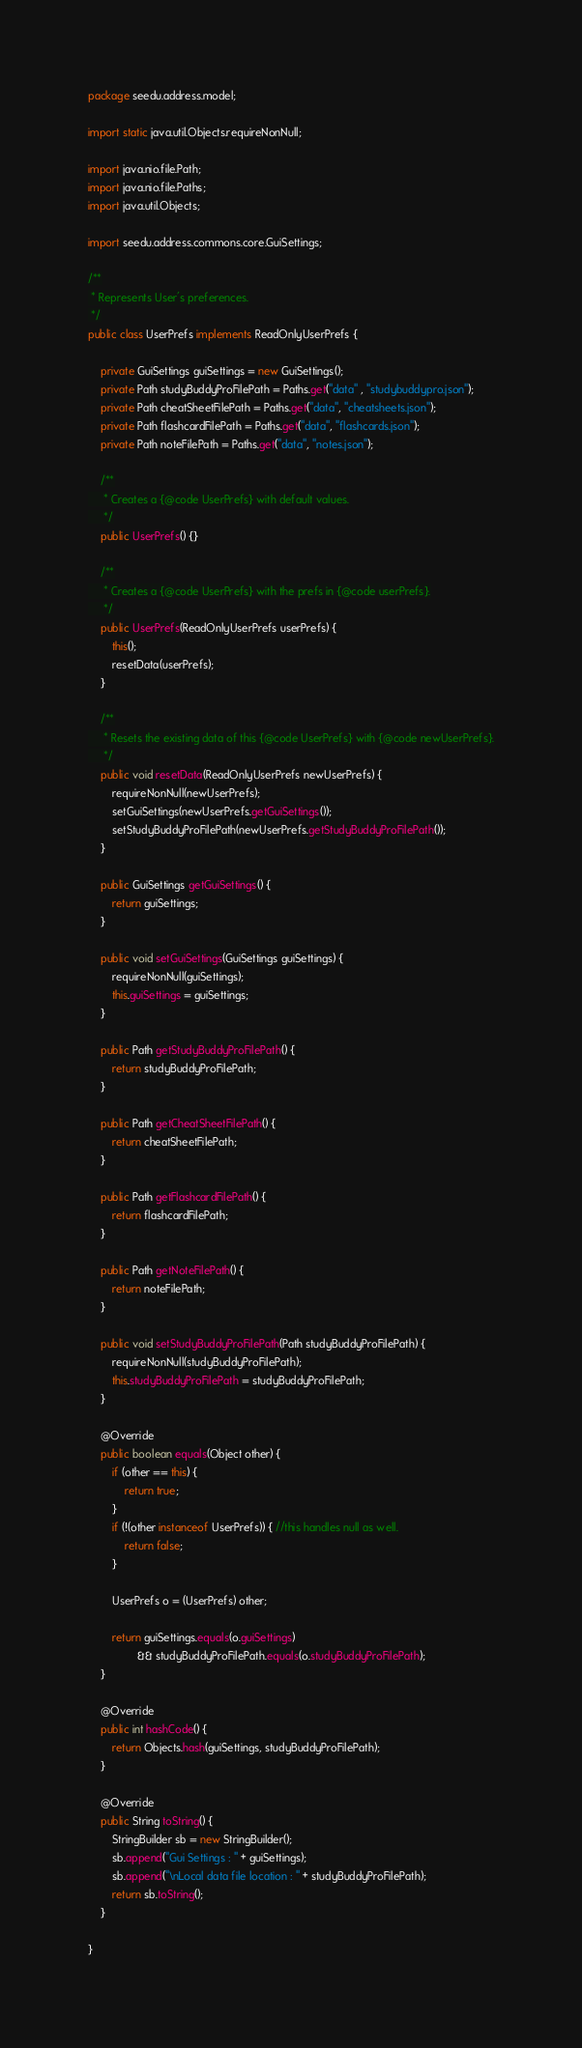<code> <loc_0><loc_0><loc_500><loc_500><_Java_>package seedu.address.model;

import static java.util.Objects.requireNonNull;

import java.nio.file.Path;
import java.nio.file.Paths;
import java.util.Objects;

import seedu.address.commons.core.GuiSettings;

/**
 * Represents User's preferences.
 */
public class UserPrefs implements ReadOnlyUserPrefs {

    private GuiSettings guiSettings = new GuiSettings();
    private Path studyBuddyProFilePath = Paths.get("data" , "studybuddypro.json");
    private Path cheatSheetFilePath = Paths.get("data", "cheatsheets.json");
    private Path flashcardFilePath = Paths.get("data", "flashcards.json");
    private Path noteFilePath = Paths.get("data", "notes.json");

    /**
     * Creates a {@code UserPrefs} with default values.
     */
    public UserPrefs() {}

    /**
     * Creates a {@code UserPrefs} with the prefs in {@code userPrefs}.
     */
    public UserPrefs(ReadOnlyUserPrefs userPrefs) {
        this();
        resetData(userPrefs);
    }

    /**
     * Resets the existing data of this {@code UserPrefs} with {@code newUserPrefs}.
     */
    public void resetData(ReadOnlyUserPrefs newUserPrefs) {
        requireNonNull(newUserPrefs);
        setGuiSettings(newUserPrefs.getGuiSettings());
        setStudyBuddyProFilePath(newUserPrefs.getStudyBuddyProFilePath());
    }

    public GuiSettings getGuiSettings() {
        return guiSettings;
    }

    public void setGuiSettings(GuiSettings guiSettings) {
        requireNonNull(guiSettings);
        this.guiSettings = guiSettings;
    }

    public Path getStudyBuddyProFilePath() {
        return studyBuddyProFilePath;
    }

    public Path getCheatSheetFilePath() {
        return cheatSheetFilePath;
    }

    public Path getFlashcardFilePath() {
        return flashcardFilePath;
    }

    public Path getNoteFilePath() {
        return noteFilePath;
    }

    public void setStudyBuddyProFilePath(Path studyBuddyProFilePath) {
        requireNonNull(studyBuddyProFilePath);
        this.studyBuddyProFilePath = studyBuddyProFilePath;
    }

    @Override
    public boolean equals(Object other) {
        if (other == this) {
            return true;
        }
        if (!(other instanceof UserPrefs)) { //this handles null as well.
            return false;
        }

        UserPrefs o = (UserPrefs) other;

        return guiSettings.equals(o.guiSettings)
                && studyBuddyProFilePath.equals(o.studyBuddyProFilePath);
    }

    @Override
    public int hashCode() {
        return Objects.hash(guiSettings, studyBuddyProFilePath);
    }

    @Override
    public String toString() {
        StringBuilder sb = new StringBuilder();
        sb.append("Gui Settings : " + guiSettings);
        sb.append("\nLocal data file location : " + studyBuddyProFilePath);
        return sb.toString();
    }

}
</code> 